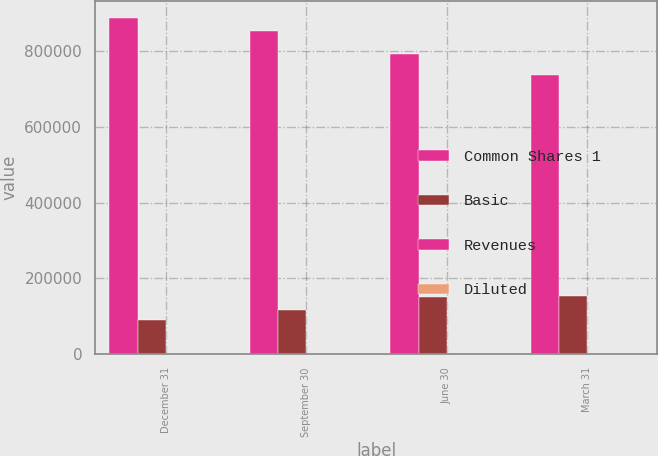<chart> <loc_0><loc_0><loc_500><loc_500><stacked_bar_chart><ecel><fcel>December 31<fcel>September 30<fcel>June 30<fcel>March 31<nl><fcel>Common Shares 1<fcel>888464<fcel>853036<fcel>792792<fcel>736337<nl><fcel>Basic<fcel>90923<fcel>116546<fcel>151625<fcel>152635<nl><fcel>Revenues<fcel>0.6<fcel>0.77<fcel>1<fcel>1.01<nl><fcel>Diluted<fcel>0.57<fcel>0.74<fcel>0.96<fcel>0.96<nl></chart> 